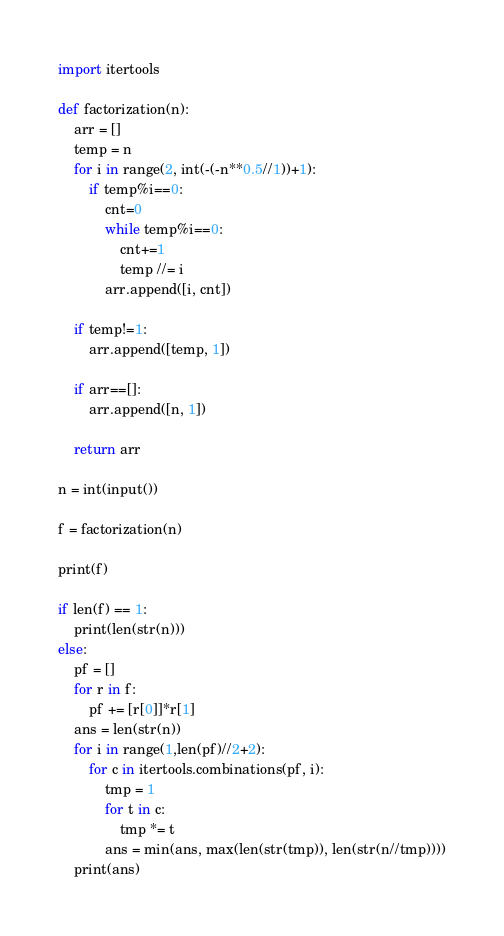Convert code to text. <code><loc_0><loc_0><loc_500><loc_500><_Python_>import itertools

def factorization(n):
    arr = []
    temp = n
    for i in range(2, int(-(-n**0.5//1))+1):
        if temp%i==0:
            cnt=0
            while temp%i==0:
                cnt+=1
                temp //= i
            arr.append([i, cnt])

    if temp!=1:
        arr.append([temp, 1])

    if arr==[]:
        arr.append([n, 1])

    return arr

n = int(input())

f = factorization(n)

print(f)

if len(f) == 1:
    print(len(str(n)))
else:
    pf = []
    for r in f:
        pf += [r[0]]*r[1]
    ans = len(str(n))
    for i in range(1,len(pf)//2+2):
        for c in itertools.combinations(pf, i):
            tmp = 1
            for t in c:
                tmp *= t
            ans = min(ans, max(len(str(tmp)), len(str(n//tmp))))
    print(ans)</code> 